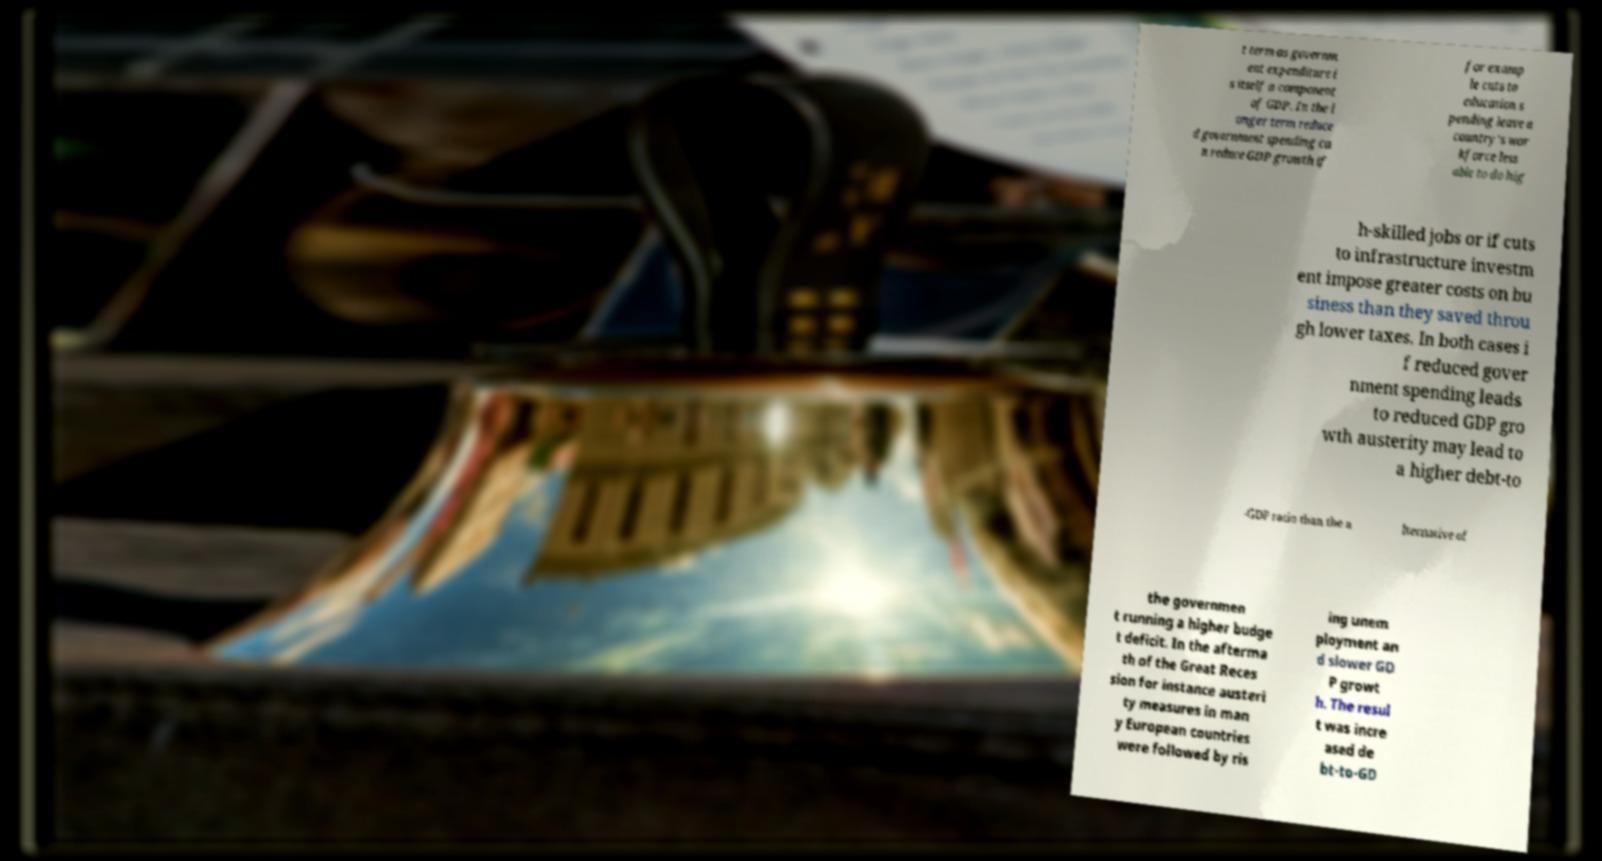Can you accurately transcribe the text from the provided image for me? t term as governm ent expenditure i s itself a component of GDP. In the l onger term reduce d government spending ca n reduce GDP growth if for examp le cuts to education s pending leave a country's wor kforce less able to do hig h-skilled jobs or if cuts to infrastructure investm ent impose greater costs on bu siness than they saved throu gh lower taxes. In both cases i f reduced gover nment spending leads to reduced GDP gro wth austerity may lead to a higher debt-to -GDP ratio than the a lternative of the governmen t running a higher budge t deficit. In the afterma th of the Great Reces sion for instance austeri ty measures in man y European countries were followed by ris ing unem ployment an d slower GD P growt h. The resul t was incre ased de bt-to-GD 